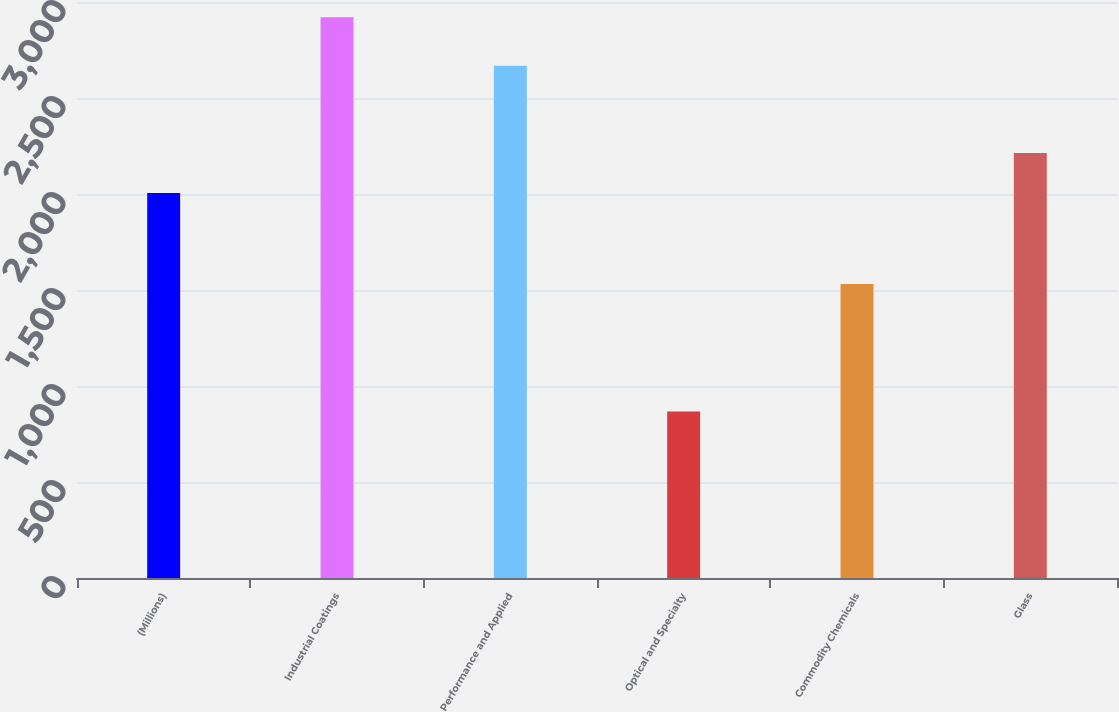<chart> <loc_0><loc_0><loc_500><loc_500><bar_chart><fcel>(Millions)<fcel>Industrial Coatings<fcel>Performance and Applied<fcel>Optical and Specialty<fcel>Commodity Chemicals<fcel>Glass<nl><fcel>2005<fcel>2921<fcel>2668<fcel>867<fcel>1531<fcel>2214<nl></chart> 